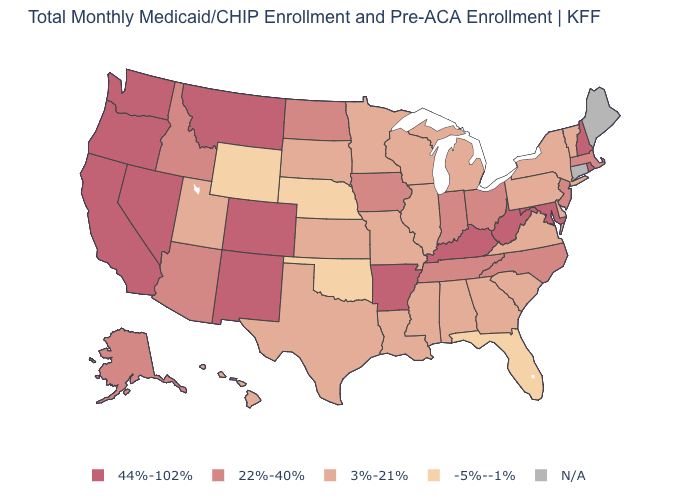Does the first symbol in the legend represent the smallest category?
Short answer required. No. What is the value of Maine?
Quick response, please. N/A. What is the value of Hawaii?
Give a very brief answer. 3%-21%. How many symbols are there in the legend?
Be succinct. 5. Name the states that have a value in the range -5%--1%?
Write a very short answer. Florida, Nebraska, Oklahoma, Wyoming. What is the lowest value in states that border Tennessee?
Write a very short answer. 3%-21%. What is the value of Michigan?
Concise answer only. 3%-21%. What is the value of Idaho?
Quick response, please. 22%-40%. Name the states that have a value in the range N/A?
Keep it brief. Connecticut, Maine. What is the value of Connecticut?
Keep it brief. N/A. Which states hav the highest value in the MidWest?
Quick response, please. Indiana, Iowa, North Dakota, Ohio. Does the first symbol in the legend represent the smallest category?
Short answer required. No. Does Maryland have the highest value in the USA?
Short answer required. Yes. Does the map have missing data?
Concise answer only. Yes. 